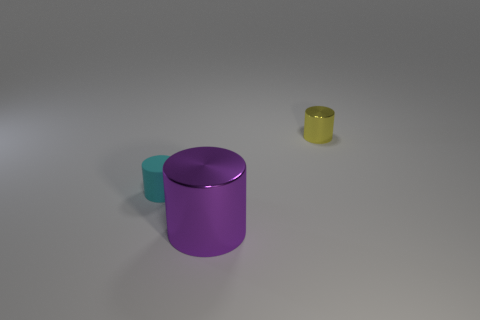Subtract all purple cylinders. How many cylinders are left? 2 Subtract all purple cylinders. How many cylinders are left? 2 Subtract 1 cylinders. How many cylinders are left? 2 Subtract all large metal cylinders. Subtract all cyan cylinders. How many objects are left? 1 Add 3 small yellow metallic cylinders. How many small yellow metallic cylinders are left? 4 Add 1 yellow rubber objects. How many yellow rubber objects exist? 1 Add 1 cyan cylinders. How many objects exist? 4 Subtract 0 blue cubes. How many objects are left? 3 Subtract all yellow cylinders. Subtract all purple spheres. How many cylinders are left? 2 Subtract all yellow balls. How many green cylinders are left? 0 